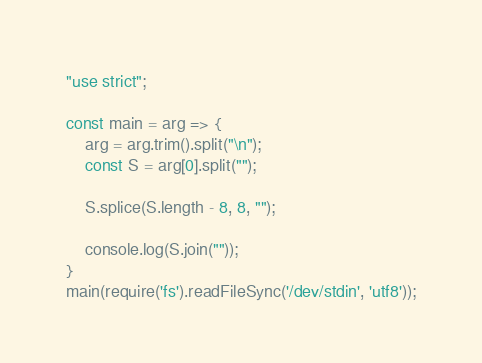Convert code to text. <code><loc_0><loc_0><loc_500><loc_500><_JavaScript_>"use strict";
    
const main = arg => {
    arg = arg.trim().split("\n");
    const S = arg[0].split("");
    
    S.splice(S.length - 8, 8, "");
    
    console.log(S.join(""));
}
main(require('fs').readFileSync('/dev/stdin', 'utf8'));</code> 